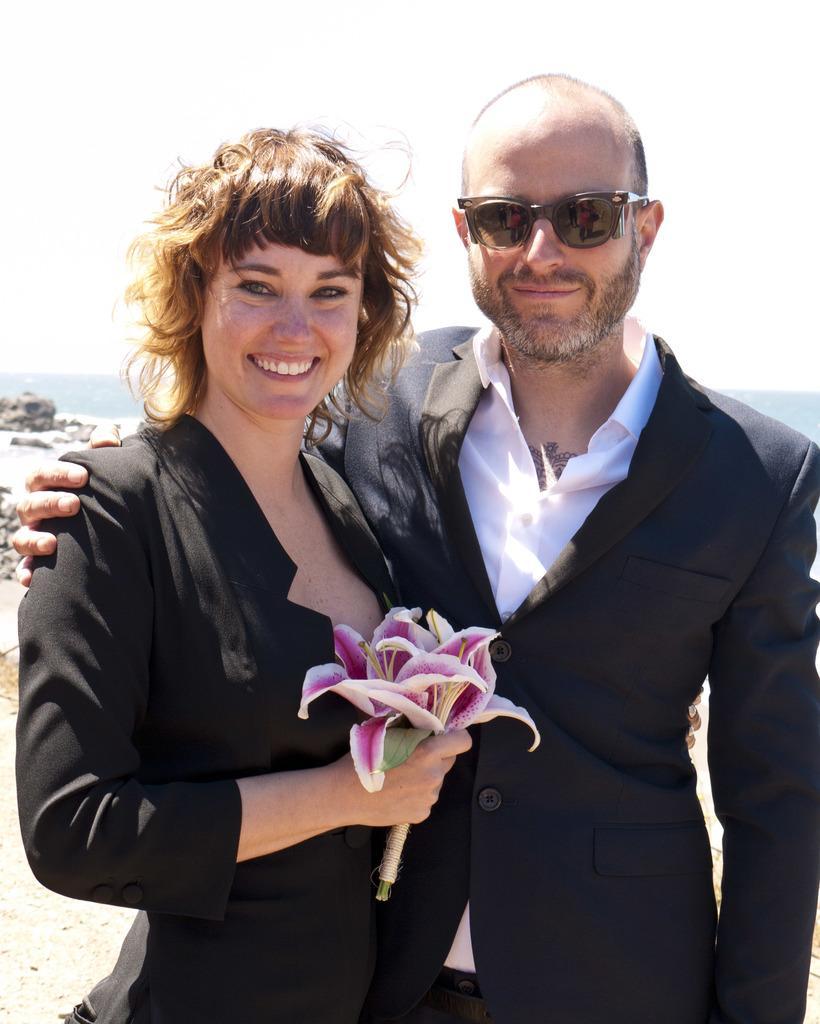Describe this image in one or two sentences. In this picture I can see in the middle a woman is standing by holding the flowers, on the right side a man is standing and wearing the black color coat. 